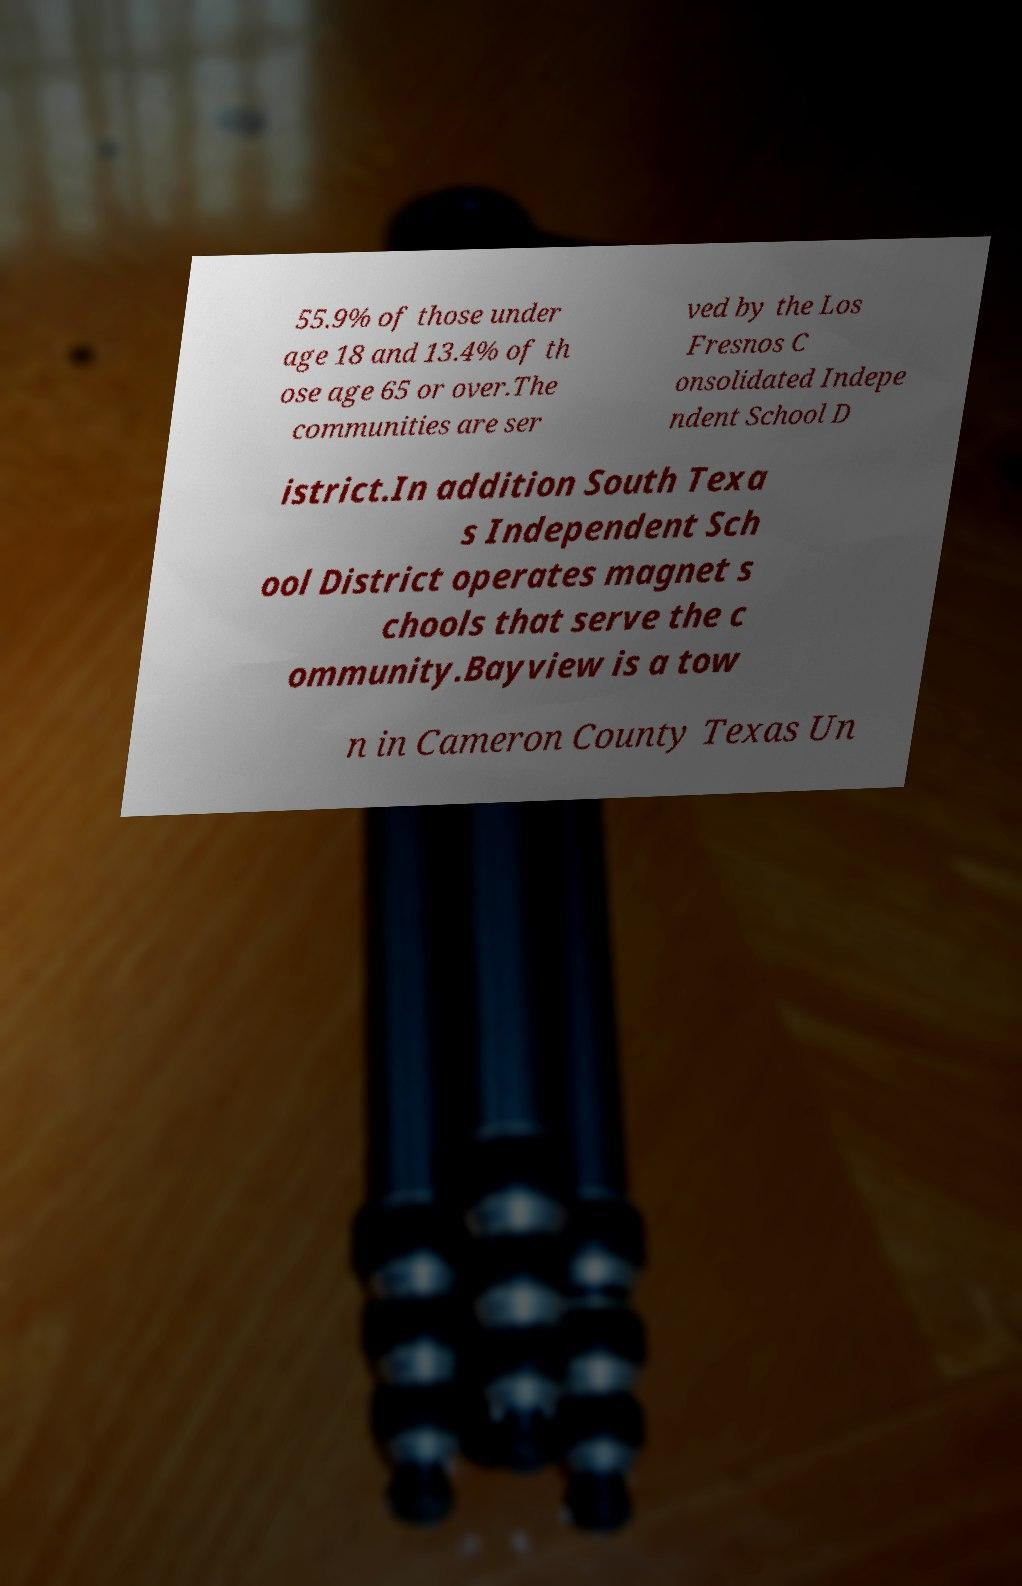Can you accurately transcribe the text from the provided image for me? 55.9% of those under age 18 and 13.4% of th ose age 65 or over.The communities are ser ved by the Los Fresnos C onsolidated Indepe ndent School D istrict.In addition South Texa s Independent Sch ool District operates magnet s chools that serve the c ommunity.Bayview is a tow n in Cameron County Texas Un 